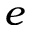Convert formula to latex. <formula><loc_0><loc_0><loc_500><loc_500>e</formula> 